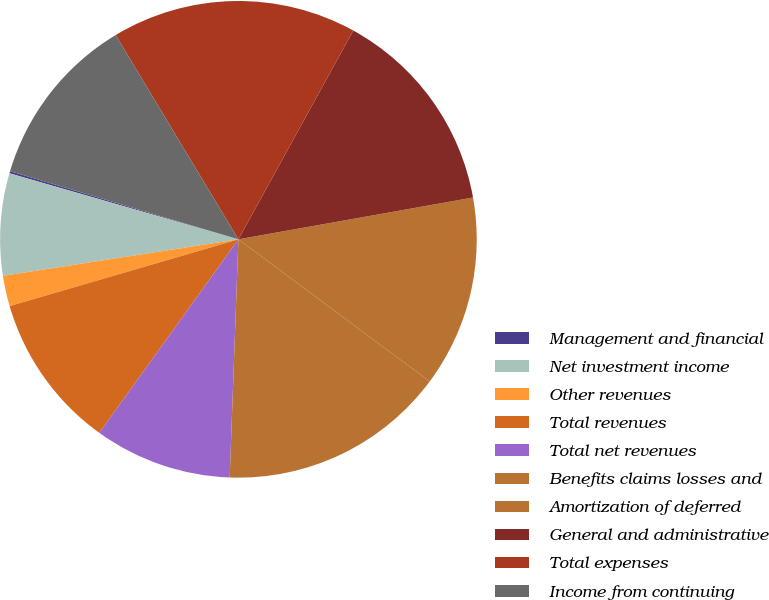Convert chart to OTSL. <chart><loc_0><loc_0><loc_500><loc_500><pie_chart><fcel>Management and financial<fcel>Net investment income<fcel>Other revenues<fcel>Total revenues<fcel>Total net revenues<fcel>Benefits claims losses and<fcel>Amortization of deferred<fcel>General and administrative<fcel>Total expenses<fcel>Income from continuing<nl><fcel>0.15%<fcel>6.92%<fcel>2.07%<fcel>10.56%<fcel>9.34%<fcel>15.41%<fcel>12.98%<fcel>14.19%<fcel>16.62%<fcel>11.77%<nl></chart> 